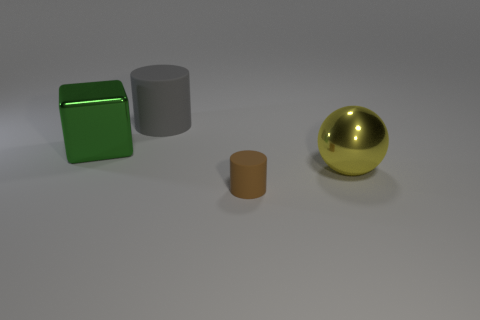Add 1 green cubes. How many objects exist? 5 Subtract all balls. How many objects are left? 3 Add 4 brown cylinders. How many brown cylinders are left? 5 Add 2 gray cylinders. How many gray cylinders exist? 3 Subtract 1 brown cylinders. How many objects are left? 3 Subtract all large yellow spheres. Subtract all small gray metal cylinders. How many objects are left? 3 